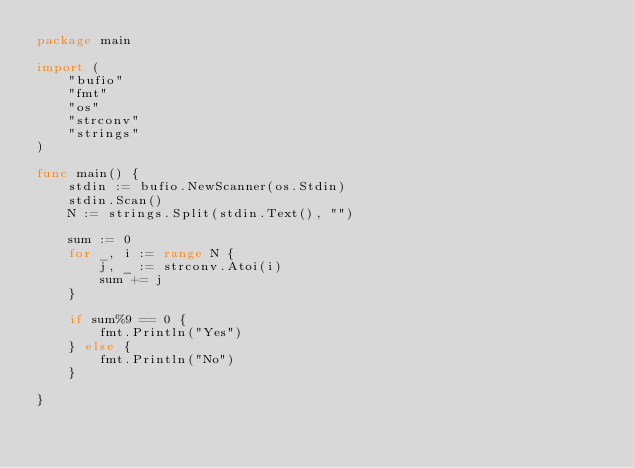Convert code to text. <code><loc_0><loc_0><loc_500><loc_500><_Go_>package main

import (
	"bufio"
	"fmt"
	"os"
	"strconv"
	"strings"
)

func main() {
	stdin := bufio.NewScanner(os.Stdin)
	stdin.Scan()
	N := strings.Split(stdin.Text(), "")

	sum := 0
	for _, i := range N {
		j, _ := strconv.Atoi(i)
		sum += j
	}

	if sum%9 == 0 {
		fmt.Println("Yes")
	} else {
		fmt.Println("No")
	}

}
</code> 